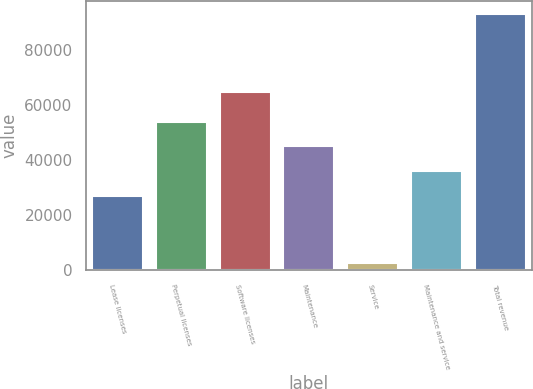Convert chart to OTSL. <chart><loc_0><loc_0><loc_500><loc_500><bar_chart><fcel>Lease licenses<fcel>Perpetual licenses<fcel>Software licenses<fcel>Maintenance<fcel>Service<fcel>Maintenance and service<fcel>Total revenue<nl><fcel>26873<fcel>53962.1<fcel>64867<fcel>44932.4<fcel>2702<fcel>35902.7<fcel>92999<nl></chart> 